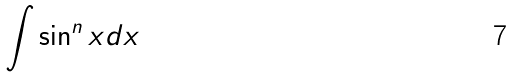Convert formula to latex. <formula><loc_0><loc_0><loc_500><loc_500>\int \sin ^ { n } x d x</formula> 